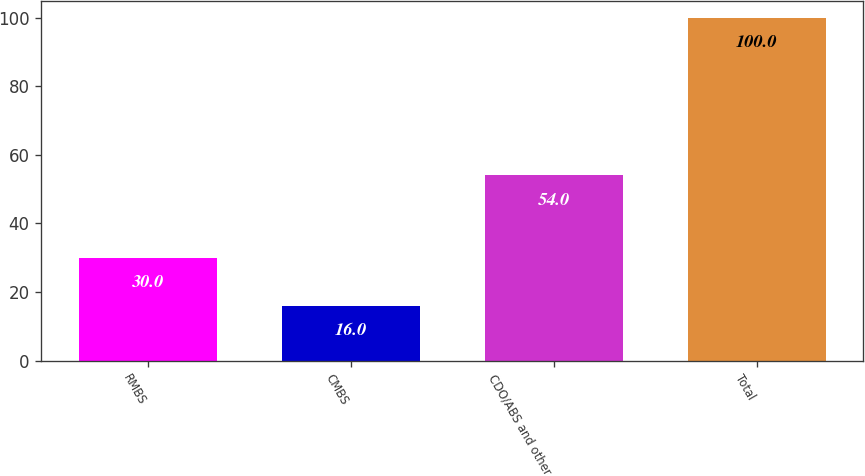<chart> <loc_0><loc_0><loc_500><loc_500><bar_chart><fcel>RMBS<fcel>CMBS<fcel>CDO/ABS and other<fcel>Total<nl><fcel>30<fcel>16<fcel>54<fcel>100<nl></chart> 